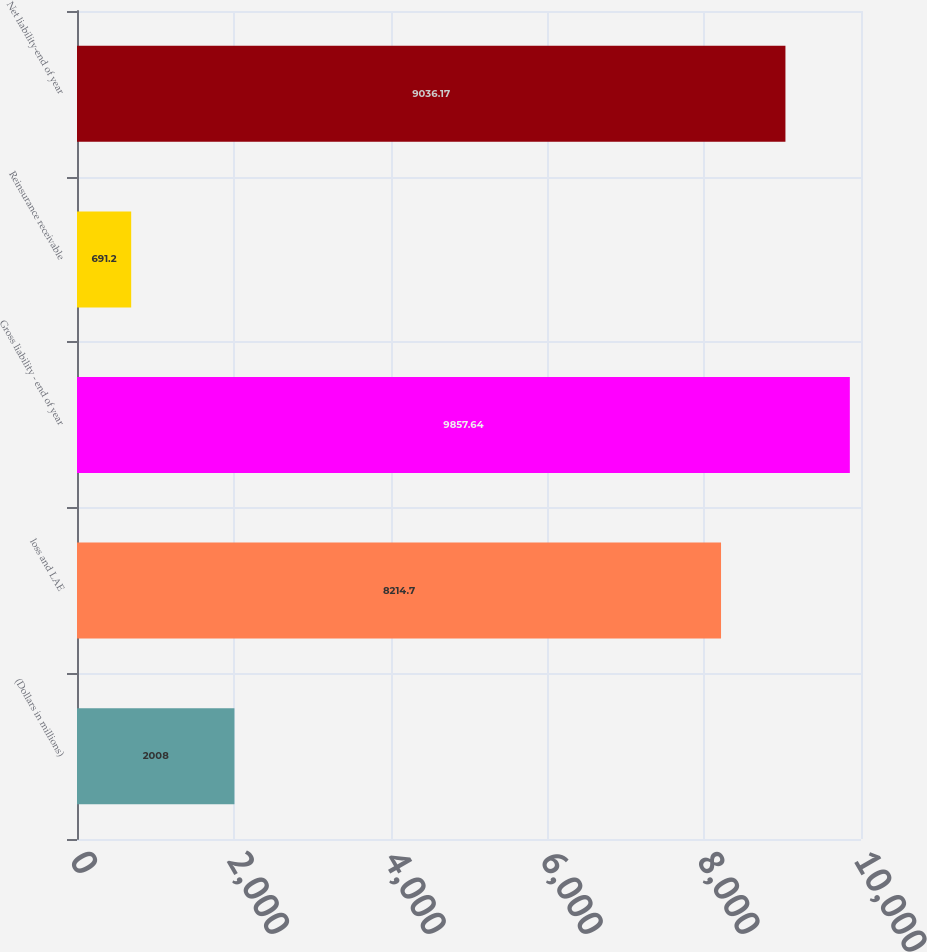Convert chart. <chart><loc_0><loc_0><loc_500><loc_500><bar_chart><fcel>(Dollars in millions)<fcel>loss and LAE<fcel>Gross liability - end of year<fcel>Reinsurance receivable<fcel>Net liability-end of year<nl><fcel>2008<fcel>8214.7<fcel>9857.64<fcel>691.2<fcel>9036.17<nl></chart> 